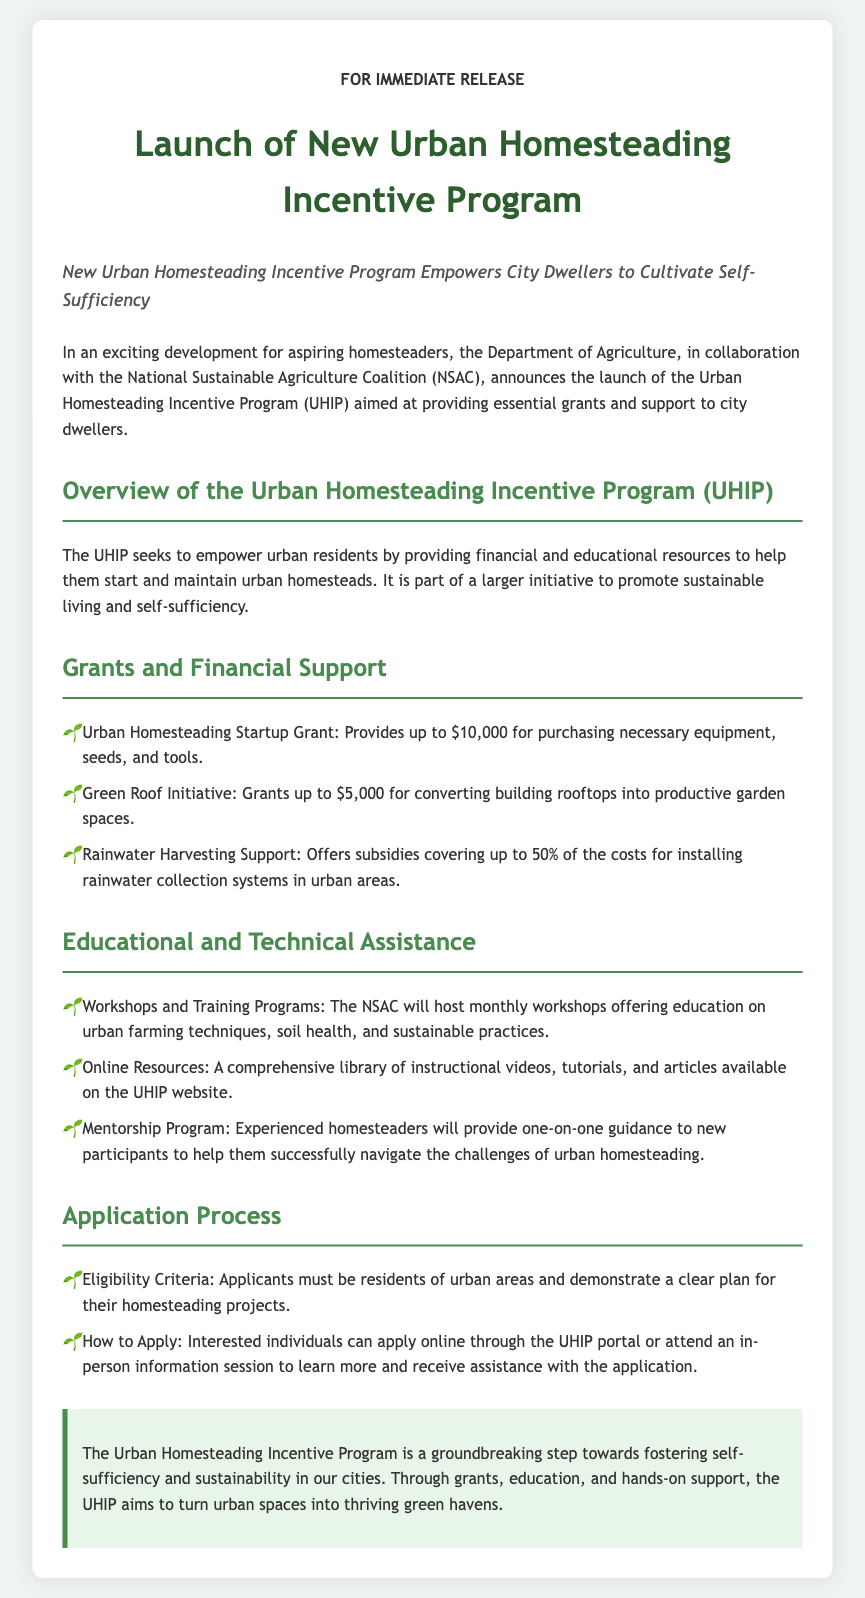what is the program launched by the Department of Agriculture? The program launched is aimed at providing essential grants and support to city dwellers, which is called the Urban Homesteading Incentive Program (UHIP).
Answer: Urban Homesteading Incentive Program (UHIP) who collaborated with the Department of Agriculture for this program? The program was launched in collaboration with the National Sustainable Agriculture Coalition (NSAC).
Answer: National Sustainable Agriculture Coalition (NSAC) what is the maximum amount provided by the Urban Homesteading Startup Grant? The Urban Homesteading Startup Grant provides up to $10,000 for necessary expenses.
Answer: $10,000 how much can be granted under the Green Roof Initiative? Under the Green Roof Initiative, grants can provide up to $5,000 for converting rooftops into gardens.
Answer: $5,000 what percentage of the costs does the Rainwater Harvesting Support cover? The Rainwater Harvesting Support offers subsidies covering up to 50% of the costs for installations.
Answer: 50% what type of support does the mentorship program offer? The mentorship program provides one-on-one guidance to new participants to help navigate urban homesteading challenges.
Answer: One-on-one guidance what is required from applicants to be eligible for the program? Applicants must demonstrate a clear plan for their homesteading projects and be residents of urban areas.
Answer: Clear plan and urban residency how can interested individuals apply for the program? Interested individuals can apply online through the UHIP portal or attend an in-person information session.
Answer: Online or in-person information session what is the aim of the Urban Homesteading Incentive Program? The aim is to foster self-sufficiency and sustainability in urban areas through grants and education.
Answer: Fostering self-sufficiency and sustainability 